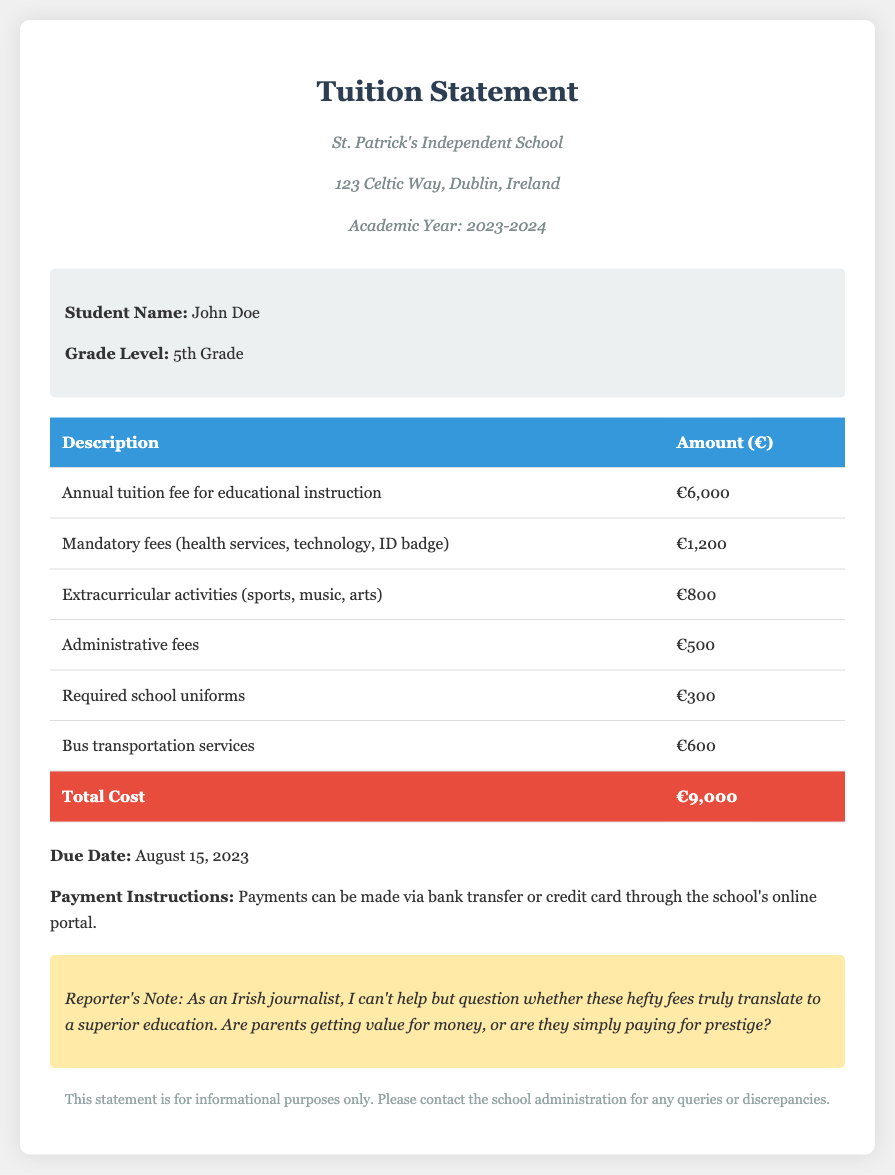What is the annual tuition fee for educational instruction? The annual tuition fee is listed in the document under "Annual tuition fee for educational instruction."
Answer: €6,000 What are mandatory fees related to? Mandatory fees are explained in the document, referring to health services, technology, and ID badge.
Answer: health services, technology, ID badge How much are the extracurricular activities? The extracurricular activities cost listed indicates the price for participation in sports, music, and arts.
Answer: €800 What is the total cost according to the tuition statement? The total cost is calculated by summing all individual costs listed in the table of the document.
Answer: €9,000 What is the due date for payment? The due date is provided clearly in the document as part of the payment information.
Answer: August 15, 2023 How much is charged for bus transportation services? The amount for bus transportation services is specified in the cost breakdown.
Answer: €600 What is the required amount for school uniforms? The required amount for school uniforms is included in the detailed breakdown of costs.
Answer: €300 Who is the student for this tuition statement? The student's name is presented at the top of the document in the student information section.
Answer: John Doe What is the note regarding value for money about? The note questions whether the fees translate to a superior education, reflecting the reporter's skepticism.
Answer: prestigious education 